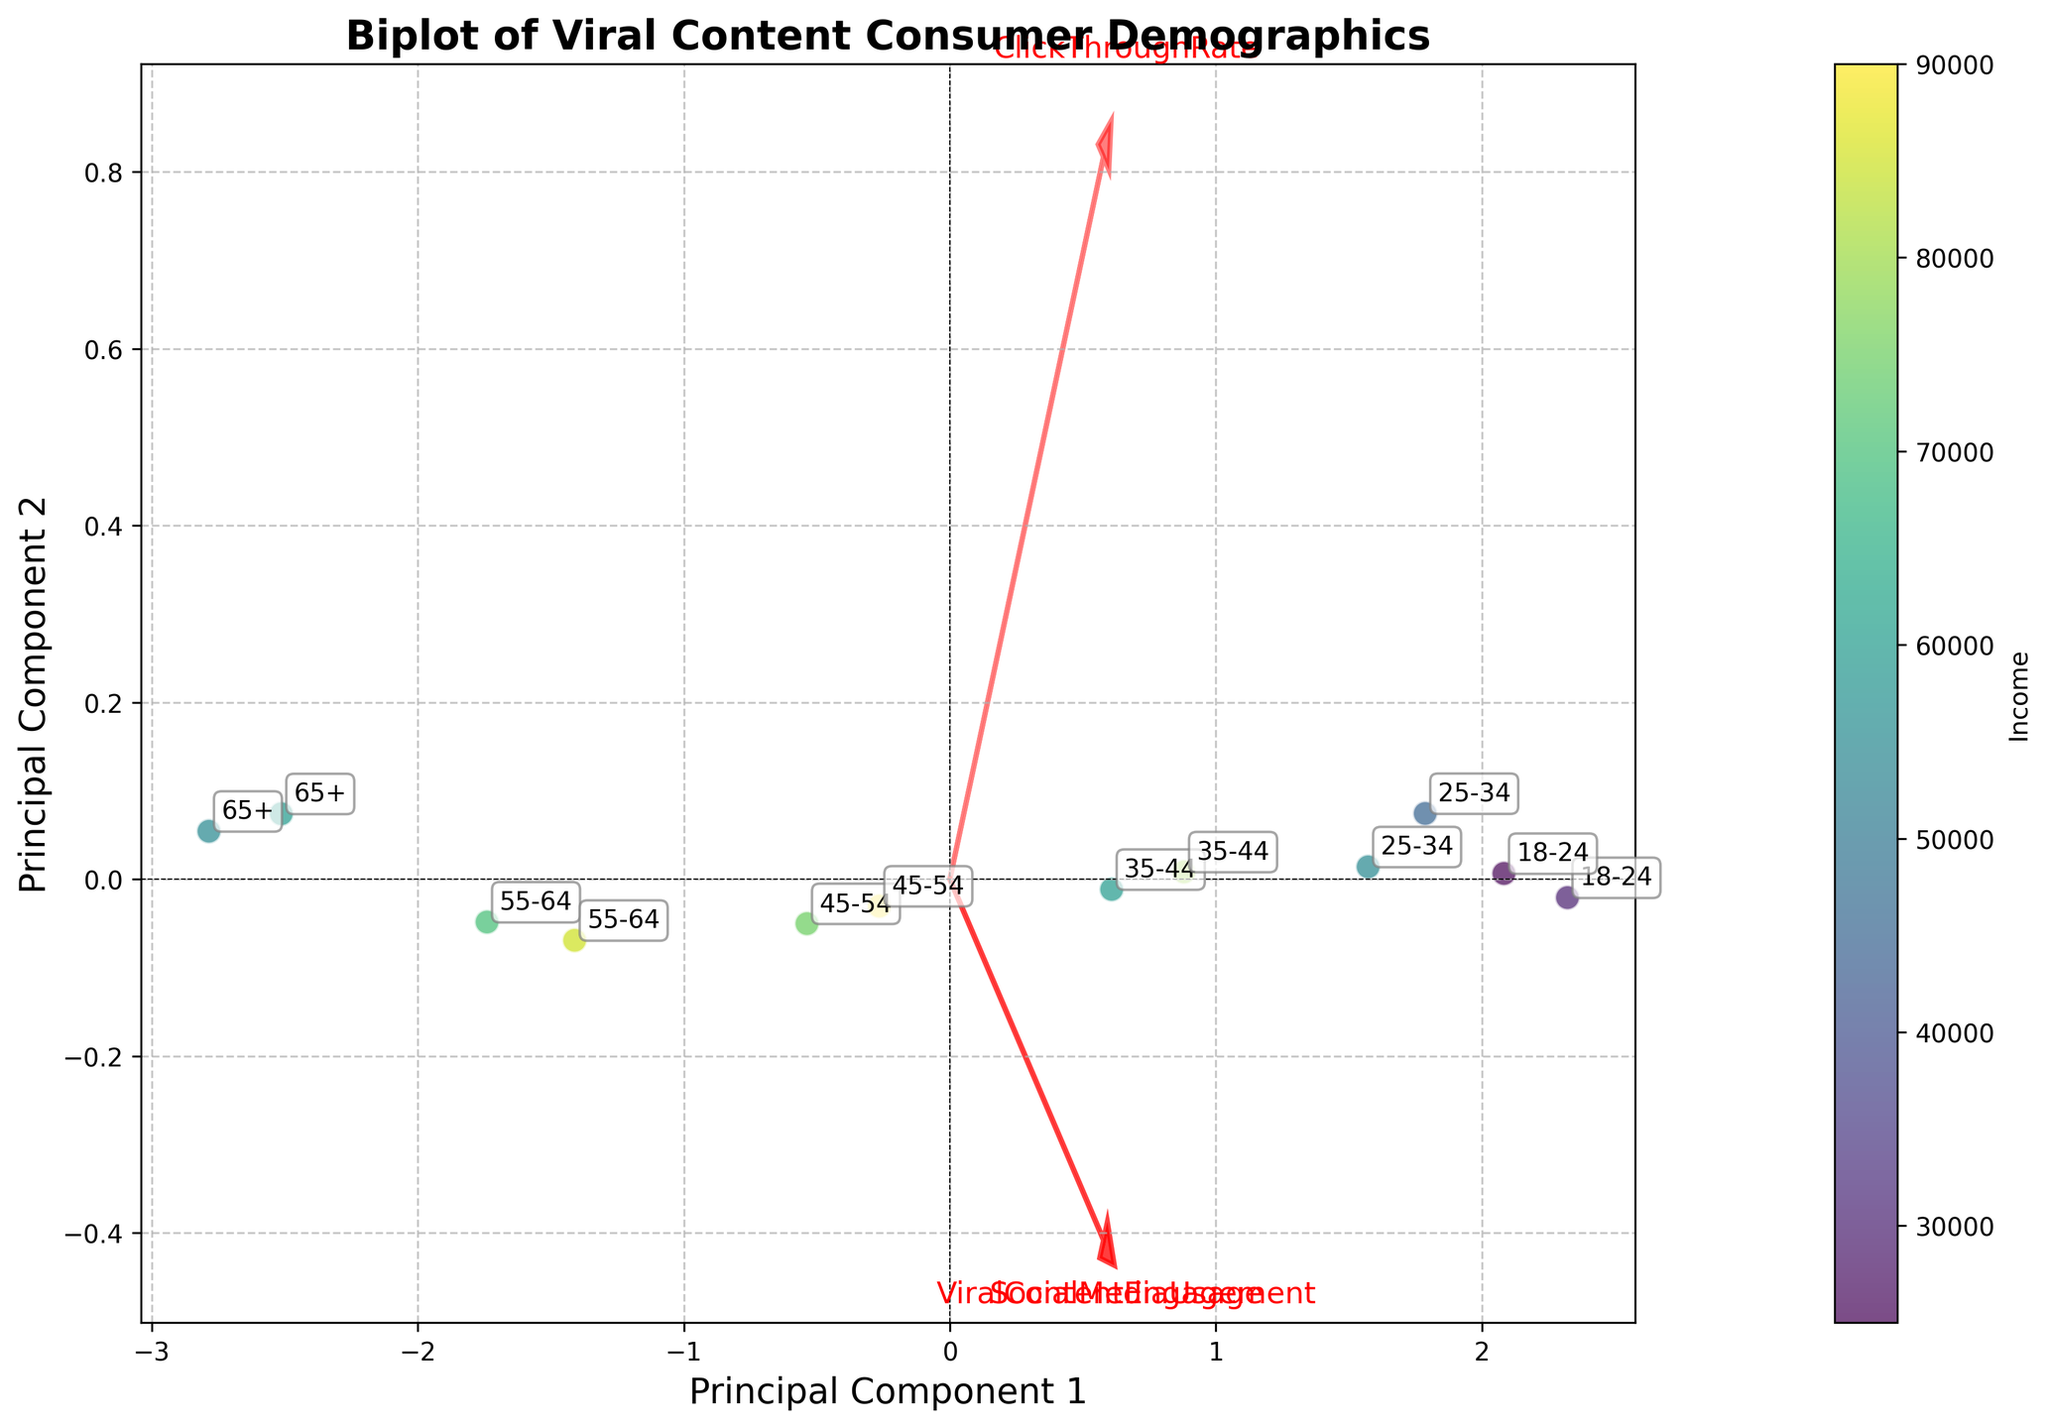what are the main axes labeling in the plot? The main axes labeling in the plot shows "Principal Component 1" on the x-axis and "Principal Component 2" on the y-axis.
Answer: Principal Component 1 and Principal Component 2 how many different age groups are represented in the plot? The plot shows various points annotated with age groups. By counting the unique labels, we can identify that there are six age groups.
Answer: 6 what direction does the 'SocialMediaUsage' feature vector point towards? By observing the red arrows and labels, the 'SocialMediaUsage' feature vector points slightly towards the upper left direction in the plot.
Answer: upper left which age group is closest to the origin (0,0)? The point nearest to the origin (0,0) is annotated with an age group label '35-44'. Therefore, the 35-44 age group is closest to the origin.
Answer: 35-44 which feature has the longest vector in the plot? By observing the lengths of the red arrows, the 'ViralContentEngagement' feature vector is the longest among the three. This can be seen as it extends further away from the origin compared to the other vectors.
Answer: ViralContentEngagement is there a positive correlation between 'ViralContentEngagement' and 'ClickThroughRate'? The arrows representing 'ViralContentEngagement' and 'ClickThroughRate' both point in the same general direction, suggesting a positive correlation between these two features.
Answer: yes which age group has the highest social media usage and where is it positioned on the plot? Observing the plot, the age group '18-24' has high social media usage. This can be seen from its position towards the upper right, close to the 'SocialMediaUsage' vector.
Answer: 18-24, upper right what is the general trend of viral content engagement with increasing age? By observing the data points from the youngest age group (18-24) to the oldest (65+), it is visible that the points move from higher positions near the 'ViralContentEngagement' vector towards lower positions, indicating a decreasing trend of engagement with increasing age.
Answer: decreases with increasing age do higher income age groups tend to have higher viral content engagement? Comparing the colors (income levels) of the points, higher income groups, such as '45-54' and '35-44', are positioned somewhat away from high 'ViralContentEngagement' vectors, suggesting they have lower engagement compared to lower income, younger groups.
Answer: no which component separates the age groups more distinctly, Principal Component 1 or Principal Component 2? By observing the dispersion of age groups along both the x-axis (Principal Component 1) and y-axis (Principal Component 2), the age groups show more distinct separation along Principal Component 1.
Answer: Principal Component 1 